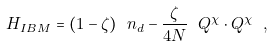<formula> <loc_0><loc_0><loc_500><loc_500>H _ { I B M } = ( 1 - \zeta ) \ n _ { d } - \frac { \zeta } { 4 N } \ Q ^ { \chi } \cdot Q ^ { \chi } \ ,</formula> 